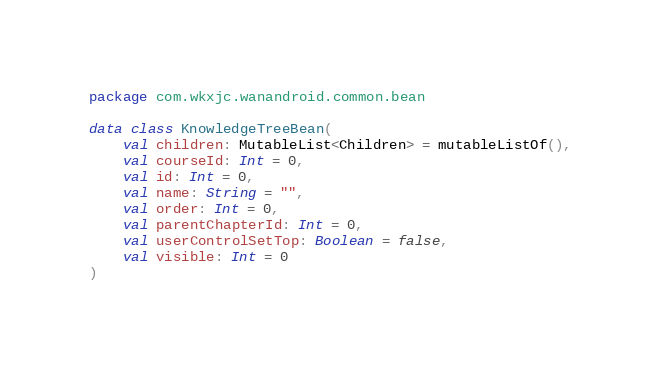Convert code to text. <code><loc_0><loc_0><loc_500><loc_500><_Kotlin_>package com.wkxjc.wanandroid.common.bean

data class KnowledgeTreeBean(
    val children: MutableList<Children> = mutableListOf(),
    val courseId: Int = 0,
    val id: Int = 0,
    val name: String = "",
    val order: Int = 0,
    val parentChapterId: Int = 0,
    val userControlSetTop: Boolean = false,
    val visible: Int = 0
)</code> 